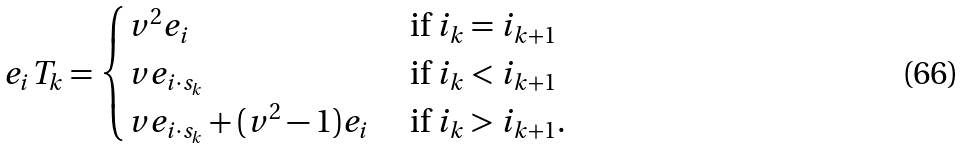<formula> <loc_0><loc_0><loc_500><loc_500>e _ { i } T _ { k } = \begin{cases} v ^ { 2 } e _ { i } & \text { if $i_{k} = i_{k+1}$} \\ v e _ { i \cdot s _ { k } } & \text { if $i_{k} < i_{k+1}$} \\ v e _ { i \cdot s _ { k } } + ( v ^ { 2 } - 1 ) e _ { i } & \text { if $i_{k} > i_{k+1}$.} \end{cases}</formula> 